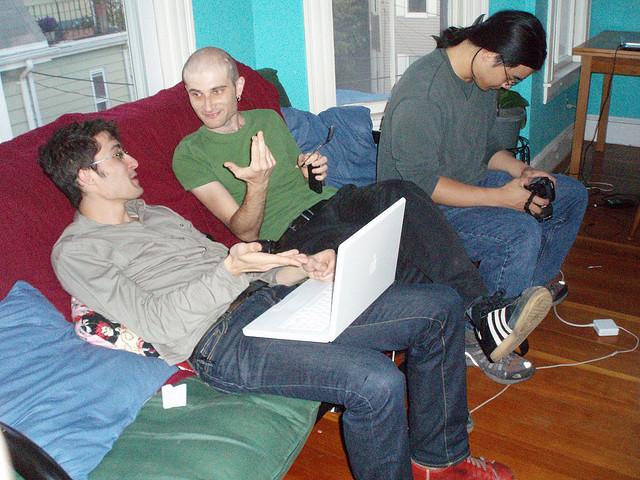What color are the walls painted?
Answer briefly. Blue. Does the red shoe match the red couch cushion?
Answer briefly. No. What is the person not engaged in conversation doing?
Give a very brief answer. Looking at camera. 